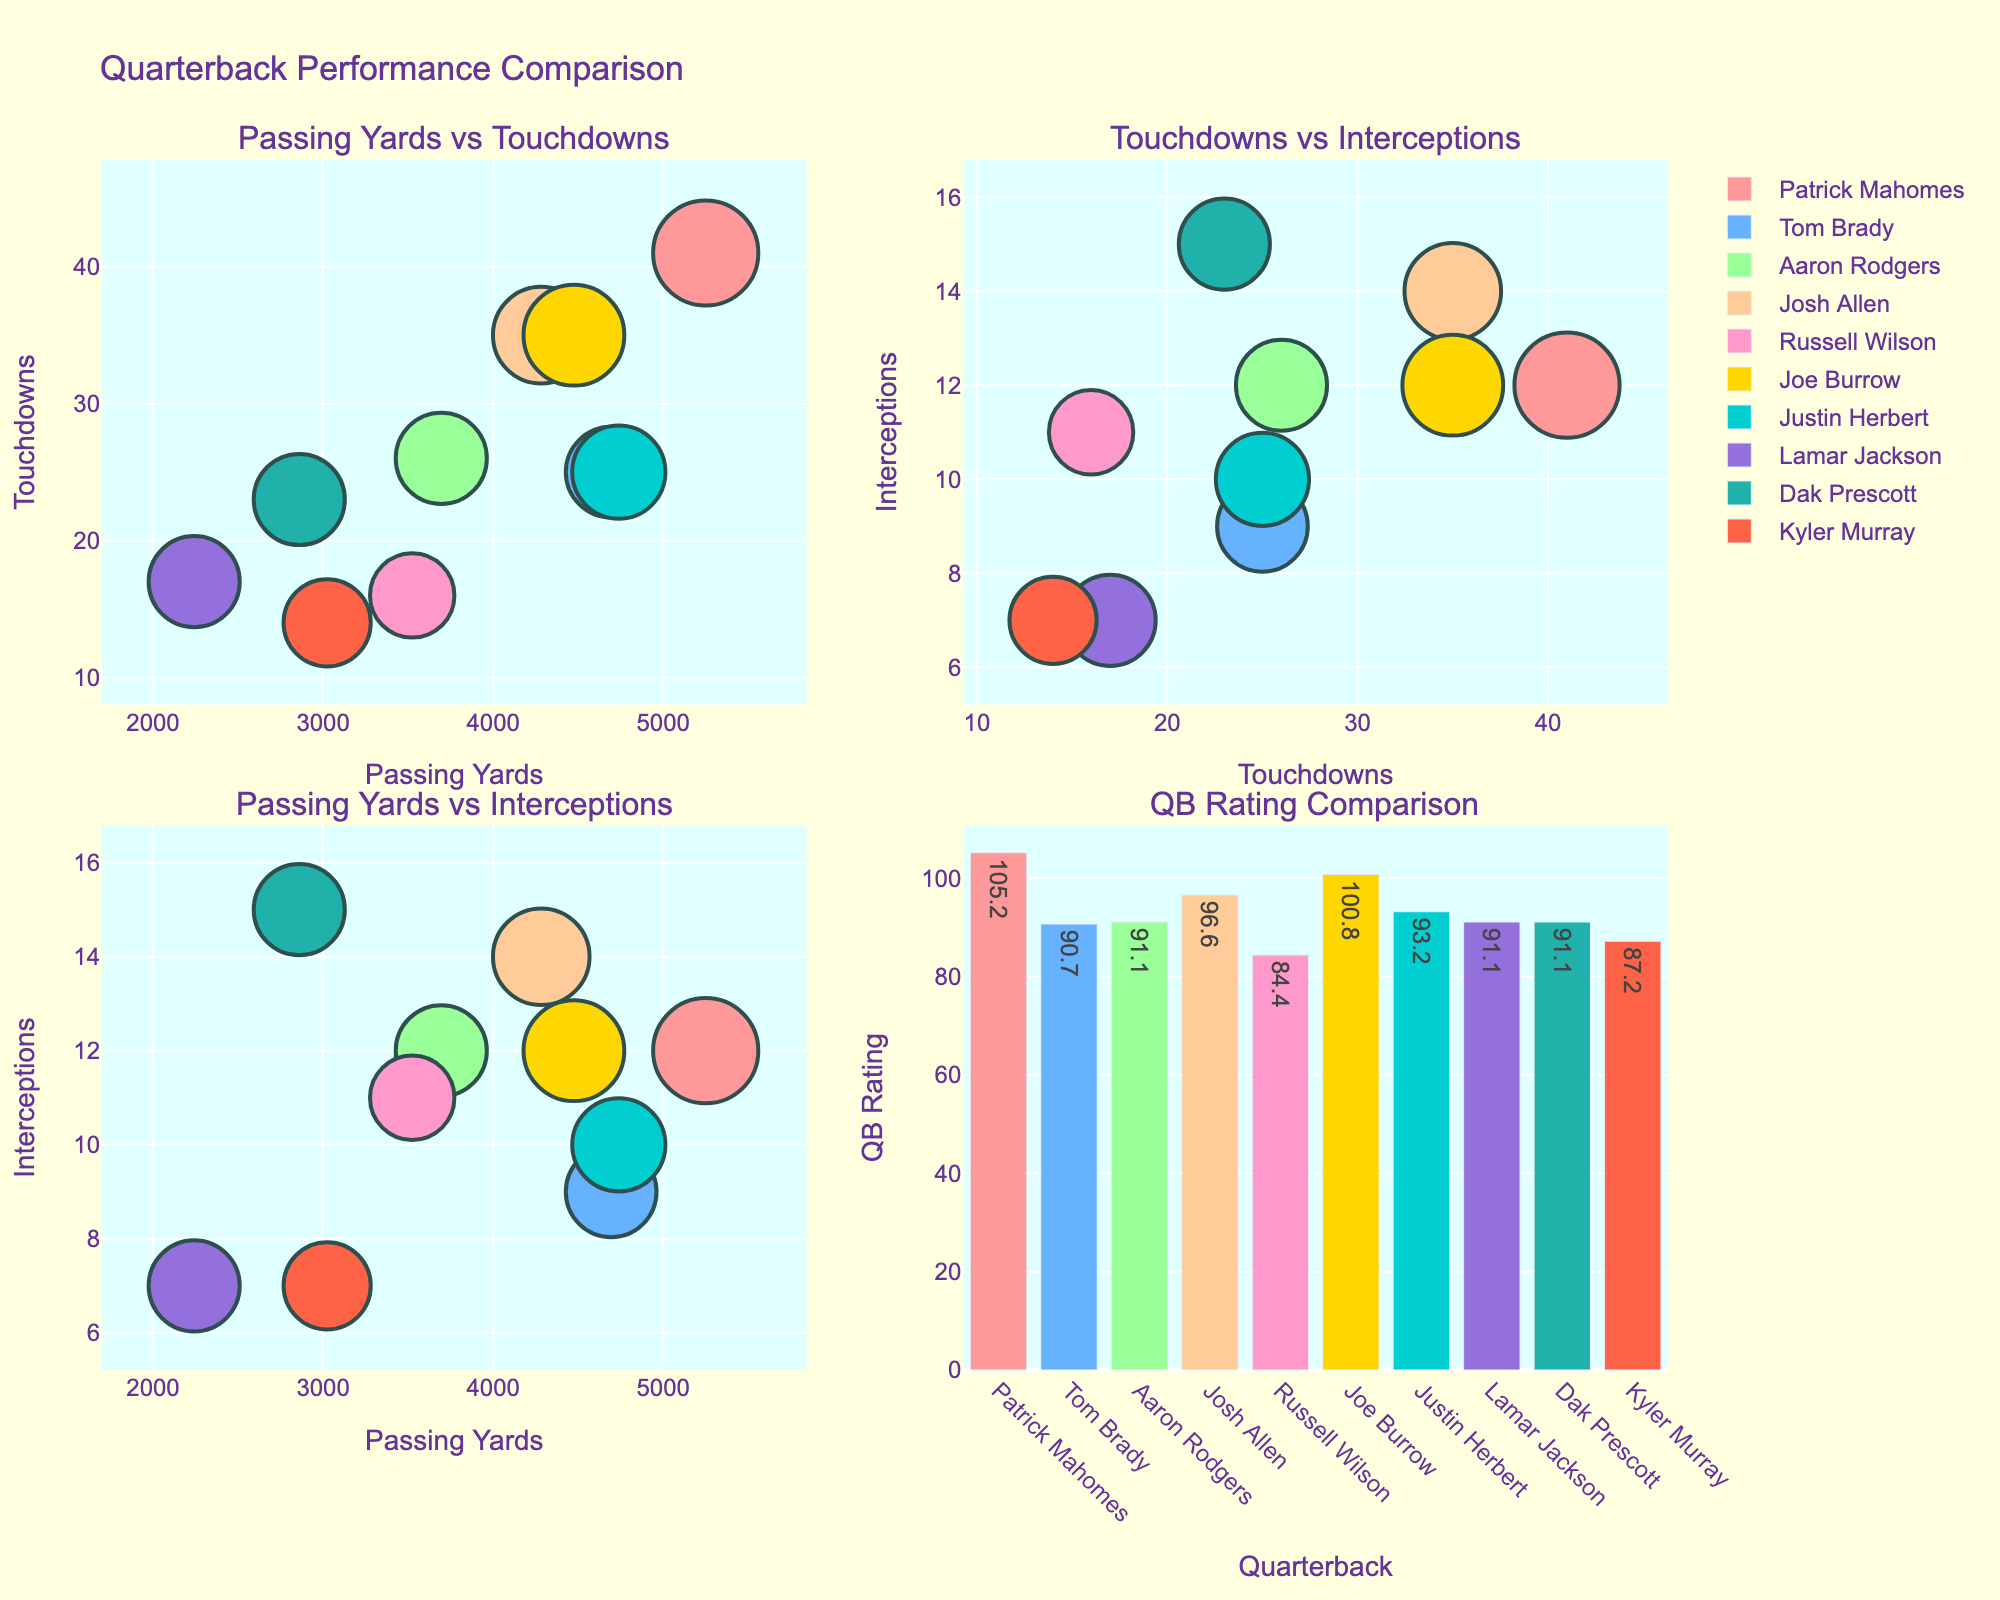what is the title of the figure? The title is located at the top of the figure, and it summarizes the overall content of the figure.
Answer: Quarterback Performance Comparison How many subplots are there in the figure? The figure is divided into distinct sections, each presenting different relationships among the data. By counting these sections, we determine the total number of subplots.
Answer: 4 Which quarterback has the largest bubble in the 'Passing Yards vs Touchdowns' subplot? The bubble size represents the QB rating. By examining the 'Passing Yards vs Touchdowns' subplot and identifying the largest bubble, we find the quarterback with the highest QB rating in this context.
Answer: Patrick Mahomes How does Patrick Mahomes compare to Tom Brady in terms of interceptions? To determine the difference in interceptions between Patrick Mahomes and Tom Brady, we look at their positions in the respective subplot where interceptions are displayed.
Answer: Mahomes has 3 more than Brady What is the average QB Rating of Patrick Mahomes and Joe Burrow? Add the QB ratings of Patrick Mahomes and Joe Burrow, then divide by 2 to get the average. This involves both addition and division.
Answer: (105.2 + 100.8)/2 = 103 Which quarterback has the lowest QB Rating, and how does this affect their bubble size? By examining the subplot that depicts QB ratings (the bar chart), identify the quarterback with the lowest value. Reason how this lower rating is reflected in the relative size of their bubble.
Answer: Russell Wilson has the lowest rating, and thus, a smaller bubble size Between Justin Herbert and Josh Allen, who has more passing yards, and by how much? Compare the passing yards of both quarterbacks as shown in the 'Passing Yards vs Touchdowns' subplot. Subtract the lower value from the higher to find the difference.
Answer: Herbert has 456 more Which subplot shows the relationship between total touchdowns and interceptions? Examine the titles of each subplot to determine which one corresponds to the given metrics. This involves identifying labels and logical connections between terms.
Answer: Touchdowns vs Interceptions What is the sum of interceptions for Lamar Jackson and Kyler Murray? Identify the number of interceptions for each of these quarterbacks from the respective subplot and add them together.
Answer: 7 + 7 = 14 In terms of QB Rating, arrange Aaron Rodgers, Dak Prescott, and Lamar Jackson in descending order. Extract the QB ratings for each of these quarterbacks, then sort them from the highest to the lowest to get the order.
Answer: Aaron Rodgers = Prescott = Jackson How does the position of Patrick Mahomes' bubble compare between the 'Passing Yards vs Interceptions' and 'Touchdowns vs Interceptions' subplots? Identify Mahomes' bubble in each subplot, noting the x and y positions, and compare these positions to draw conclusions about his performance across different metrics.
Answer: Positioned high in both (high yards, high TDs, mid interceptions) 